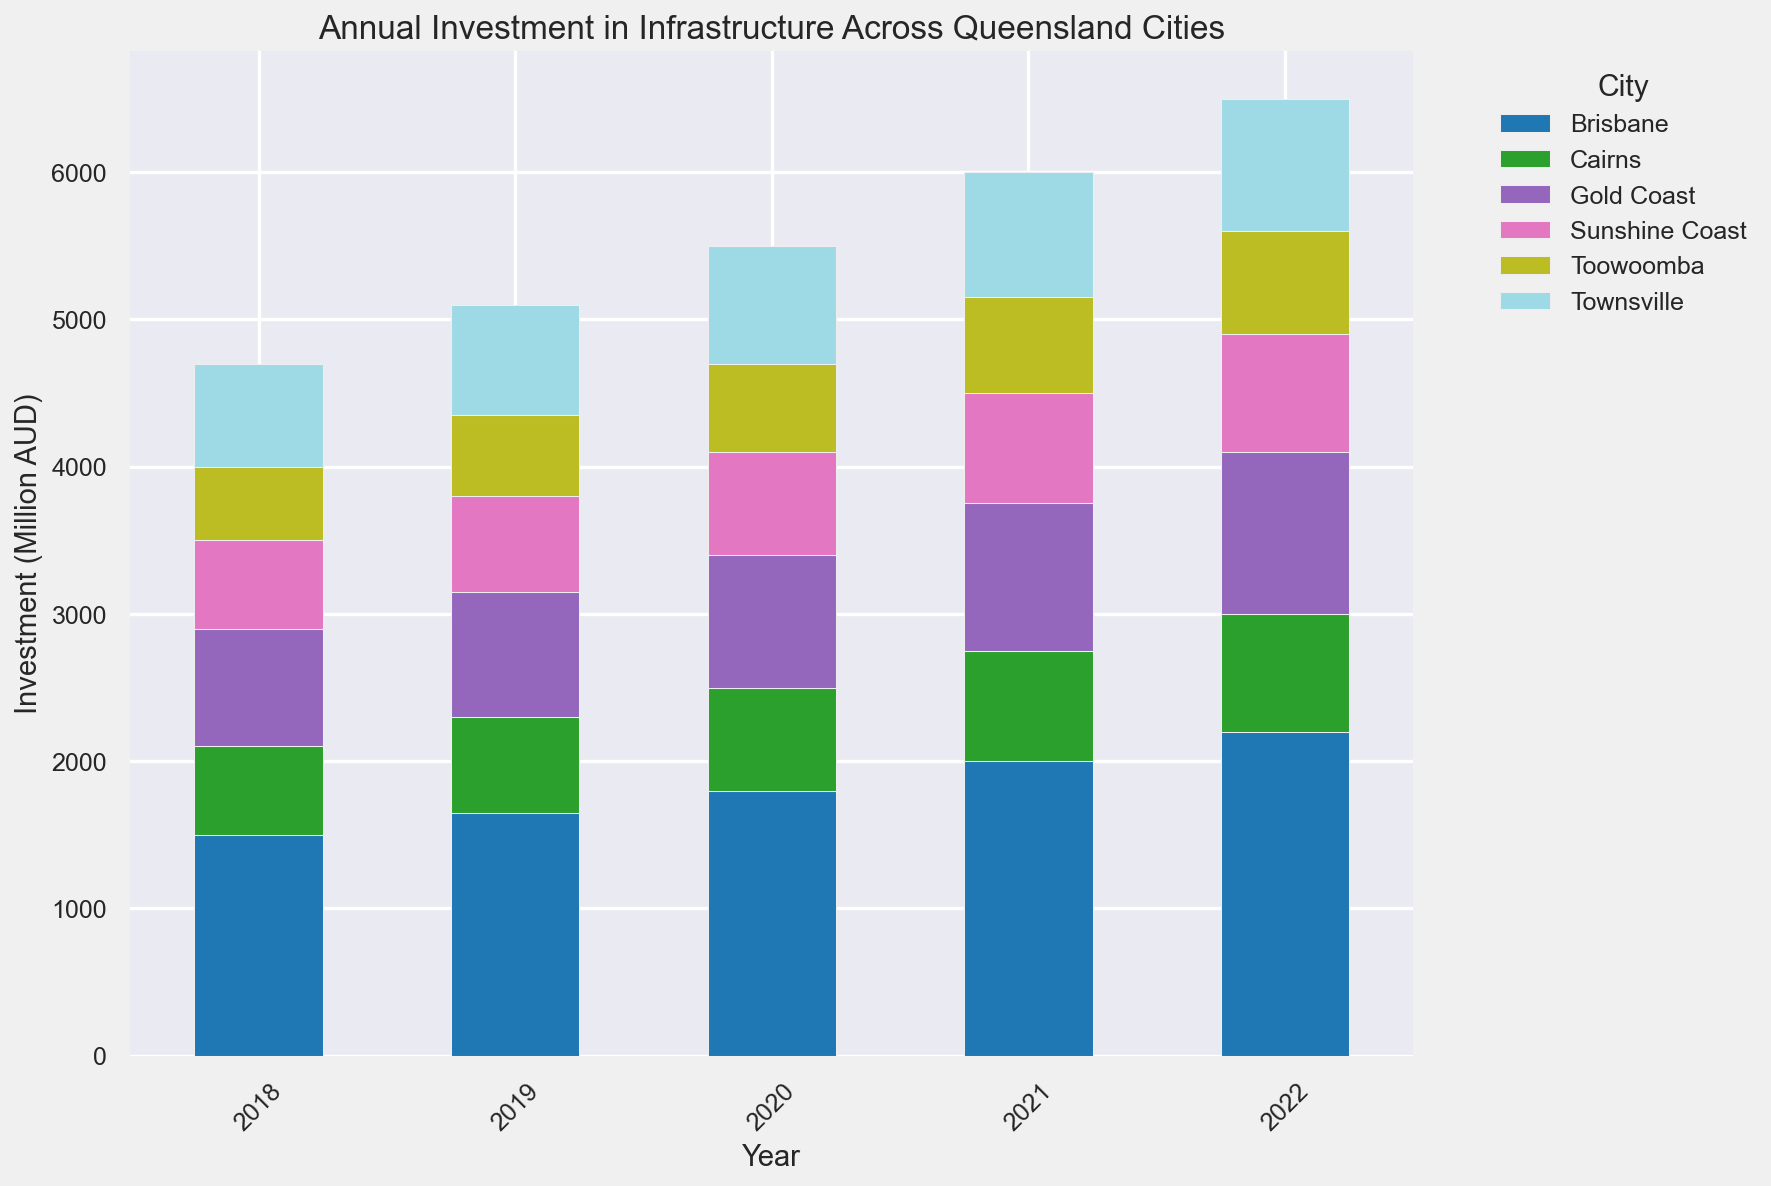What was the total investment in 2020 for all cities combined? To find the total investment in 2020, sum the investments for each city in that year. Investments are Brisbane: 1800, Gold Coast: 900, Sunshine Coast: 700, Toowoomba: 600, Townsville: 800, Cairns: 700. The total is 1800 + 900 + 700 + 600 + 800 + 700 = 5500 million AUD
Answer: 5500 million AUD Which city had the highest increase in investment from 2018 to 2022? Calculate the difference in investment between 2022 and 2018 for each city. The increases are: Brisbane (2200 - 1500 = 700), Gold Coast (1100 - 800 = 300), Sunshine Coast (800 - 600 = 200), Toowoomba (700 - 500 = 200), Townsville (900 - 700 = 200), Cairns (800 - 600 = 200). The highest increase is Brisbane with an increase of 700 million AUD
Answer: Brisbane Which year had the highest total investment across all cities? Sum the investments for all cities in each year and compare. Total investments: 2018 (1500+800+600+500+700+600 = 4700), 2019 (1650+850+650+550+750+650 = 5100), 2020 (1800+900+700+600+800+700 = 5500), 2021 (2000+1000+750+650+850+750 = 6000), 2022 (2200+1100+800+700+900+800 = 6500). The highest is in 2022 with 6500 million AUD
Answer: 2022 Which city had the lowest investment in 2021? Compare the investments for each city in 2021. Investments are: Brisbane: 2000, Gold Coast: 1000, Sunshine Coast: 750, Toowoomba: 650, Townsville: 850, Cairns: 750. Toowoomba had the lowest with 650 million AUD
Answer: Toowoomba What was the average annual investment for the Sunshine Coast over the period from 2018 to 2022? Find the sum of investments for the Sunshine Coast from 2018 to 2022 and divide by the number of years. Investments are 600, 650, 700, 750, 800. The sum is 600 + 650 + 700 + 750 + 800 = 3500. The average is 3500 / 5 = 700 million AUD per year
Answer: 700 million AUD Did Toowoomba's investment in 2020 exceed its investment in 2018 by more than 100 million AUD? Calculate the difference between Toowoomba’s investments in 2020 and 2018. The values are 600 (2020) and 500 (2018). The difference is 600 - 500 = 100 million AUD, which is not more than 100 million AUD
Answer: No, it did not Which city saw its investment doubled from 2018 to 2022? Compare the investments in 2018 and 2022 to see if any city’s investment doubled. The values are: Brisbane (1500 to 2200), Gold Coast (800 to 1100), Sunshine Coast (600 to 800), Toowoomba (500 to 700), Townsville (700 to 900), Cairns (600 to 800). None of these values doubled over the period
Answer: None What is the range of investments for Cairns during 2018 to 2022? Find the minimum and maximum investments for Cairns during this period, then calculate the range. Investments are: 600 (2018), 650 (2019), 700 (2020), 750 (2021), 800 (2022). The range is 800 - 600 = 200 million AUD
Answer: 200 million AUD 